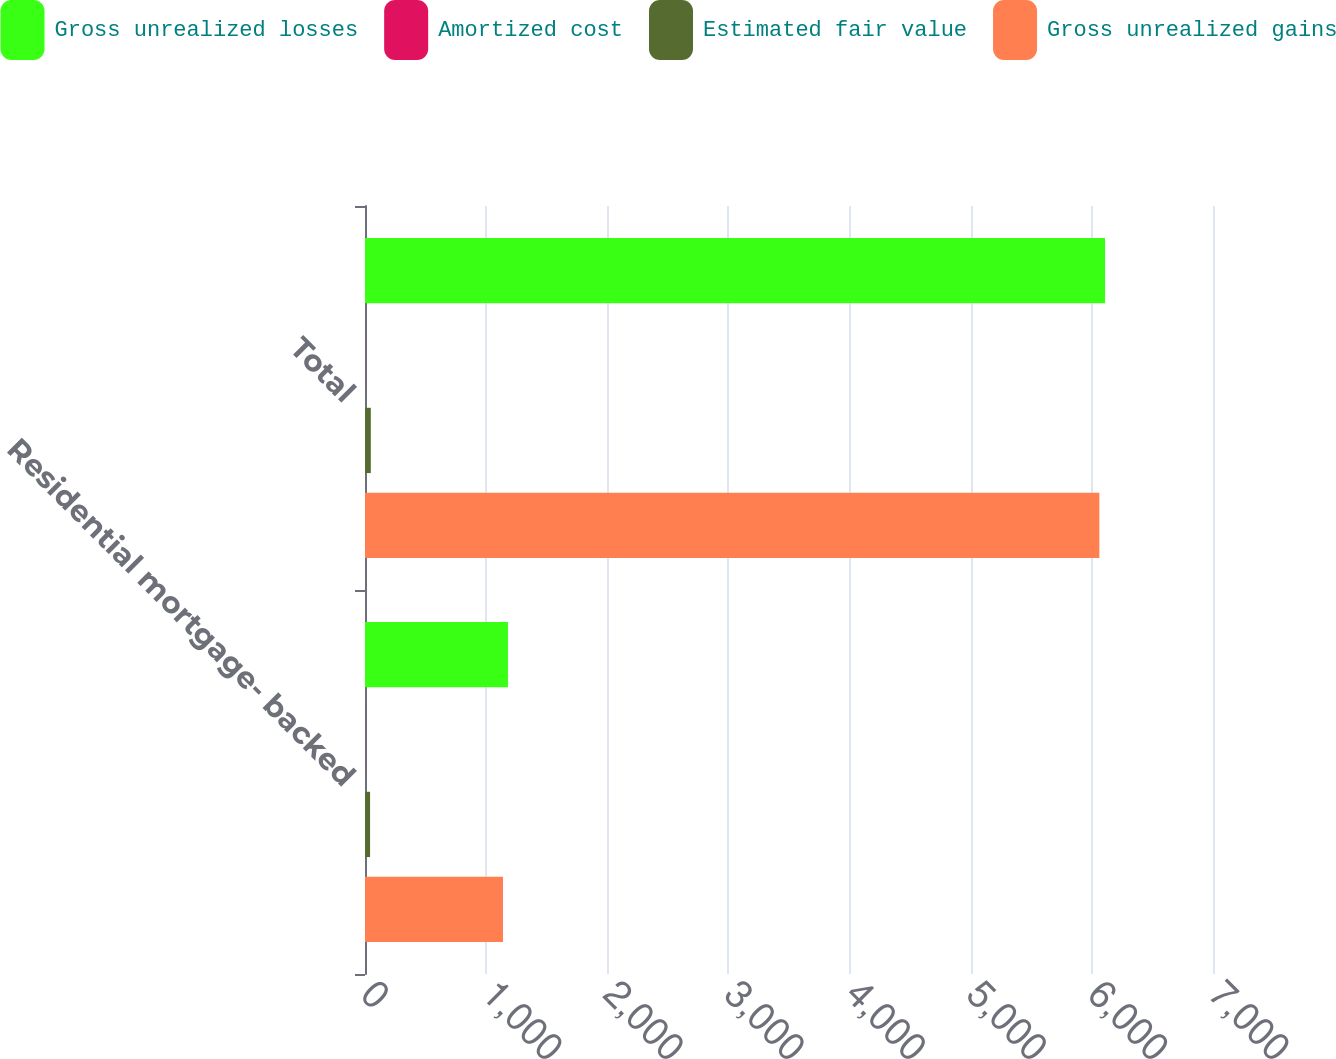Convert chart. <chart><loc_0><loc_0><loc_500><loc_500><stacked_bar_chart><ecel><fcel>Residential mortgage- backed<fcel>Total<nl><fcel>Gross unrealized losses<fcel>1180<fcel>6109<nl><fcel>Amortized cost<fcel>1<fcel>1<nl><fcel>Estimated fair value<fcel>42<fcel>48<nl><fcel>Gross unrealized gains<fcel>1139<fcel>6062<nl></chart> 